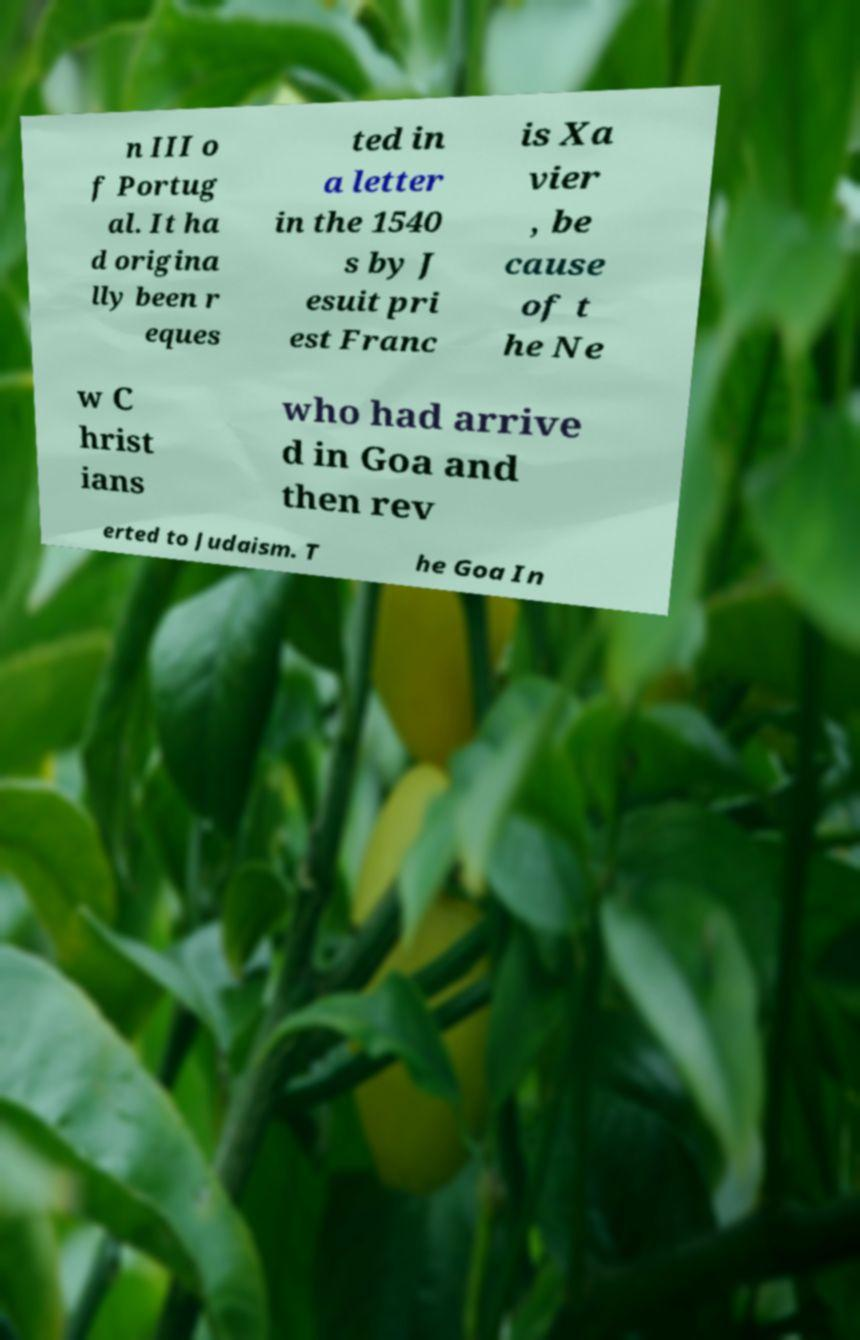Could you assist in decoding the text presented in this image and type it out clearly? n III o f Portug al. It ha d origina lly been r eques ted in a letter in the 1540 s by J esuit pri est Franc is Xa vier , be cause of t he Ne w C hrist ians who had arrive d in Goa and then rev erted to Judaism. T he Goa In 